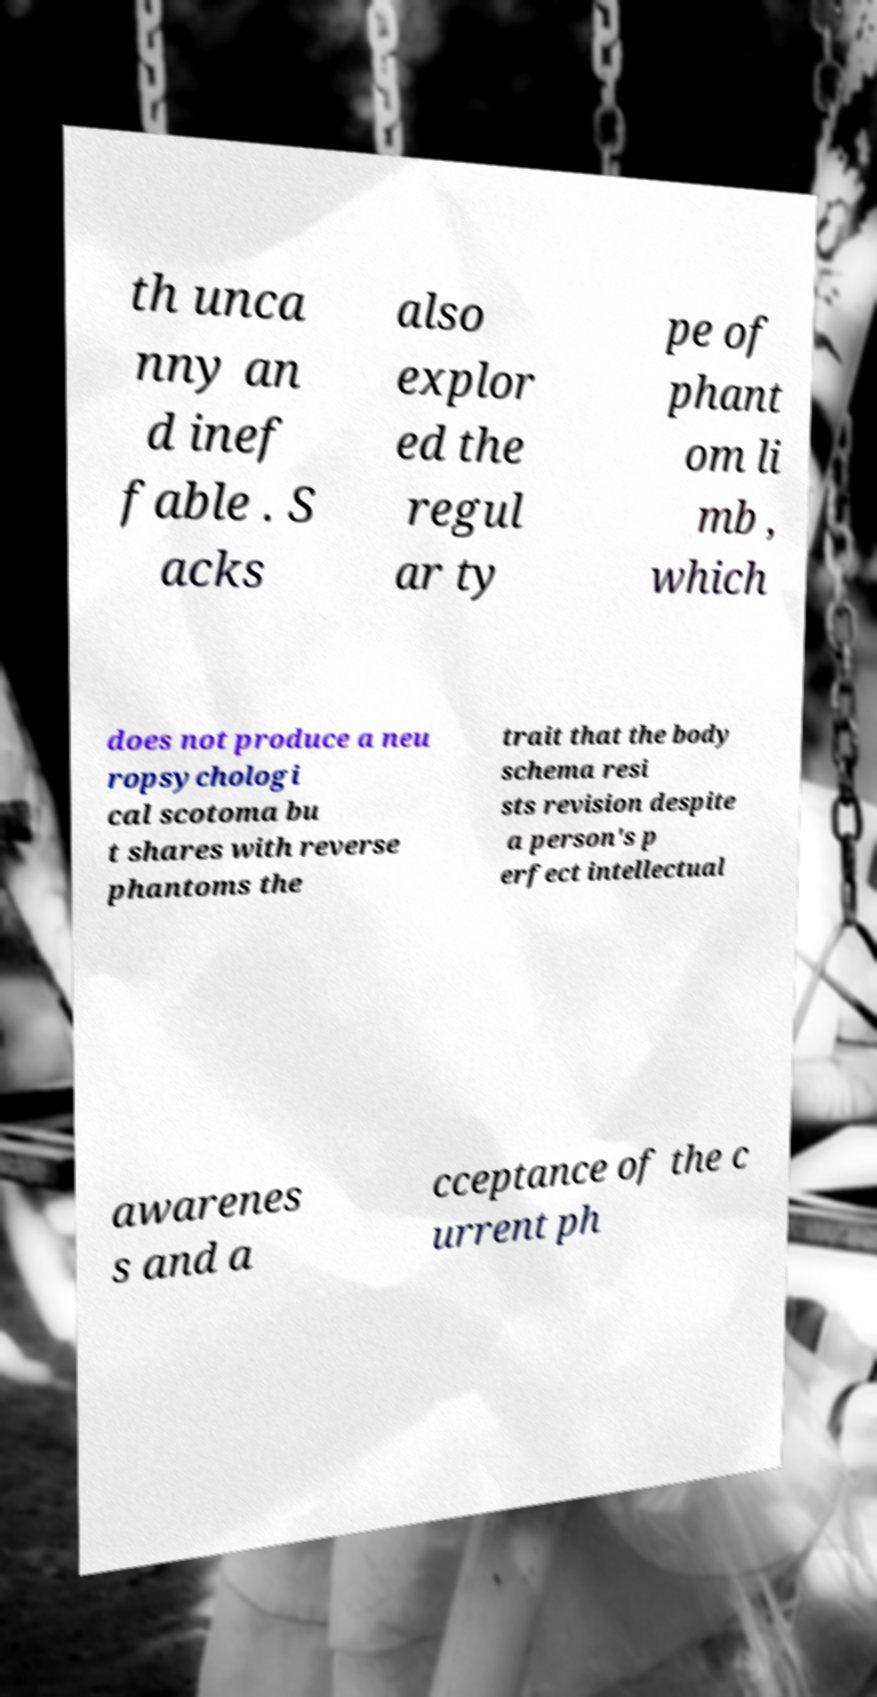What messages or text are displayed in this image? I need them in a readable, typed format. th unca nny an d inef fable . S acks also explor ed the regul ar ty pe of phant om li mb , which does not produce a neu ropsychologi cal scotoma bu t shares with reverse phantoms the trait that the body schema resi sts revision despite a person's p erfect intellectual awarenes s and a cceptance of the c urrent ph 